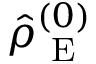<formula> <loc_0><loc_0><loc_500><loc_500>\hat { \rho } _ { E } ^ { ( 0 ) }</formula> 